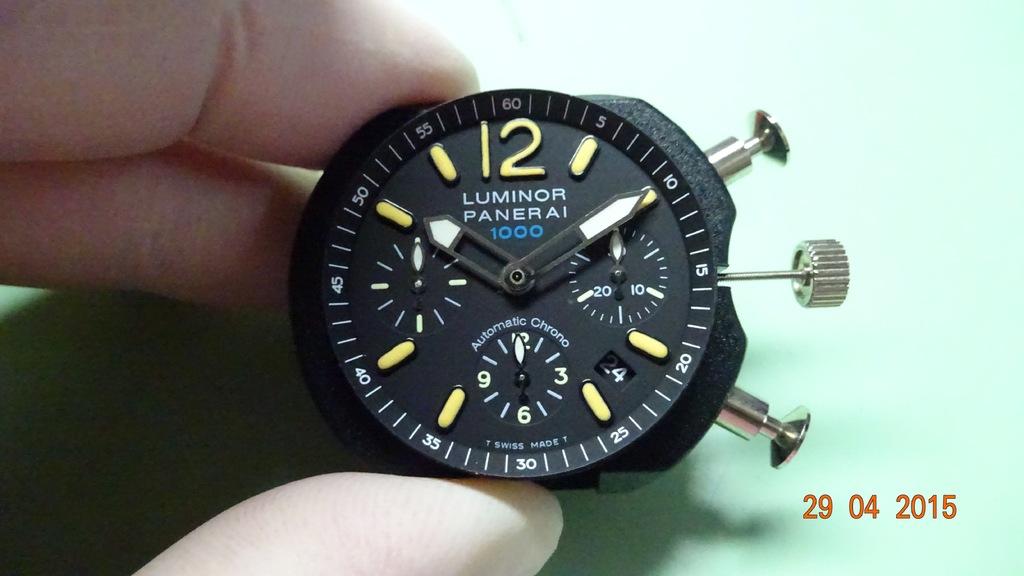What brand of watch is this?
Your response must be concise. Luminor panerai. What is the date on the right?
Make the answer very short. 20 04 2015. 